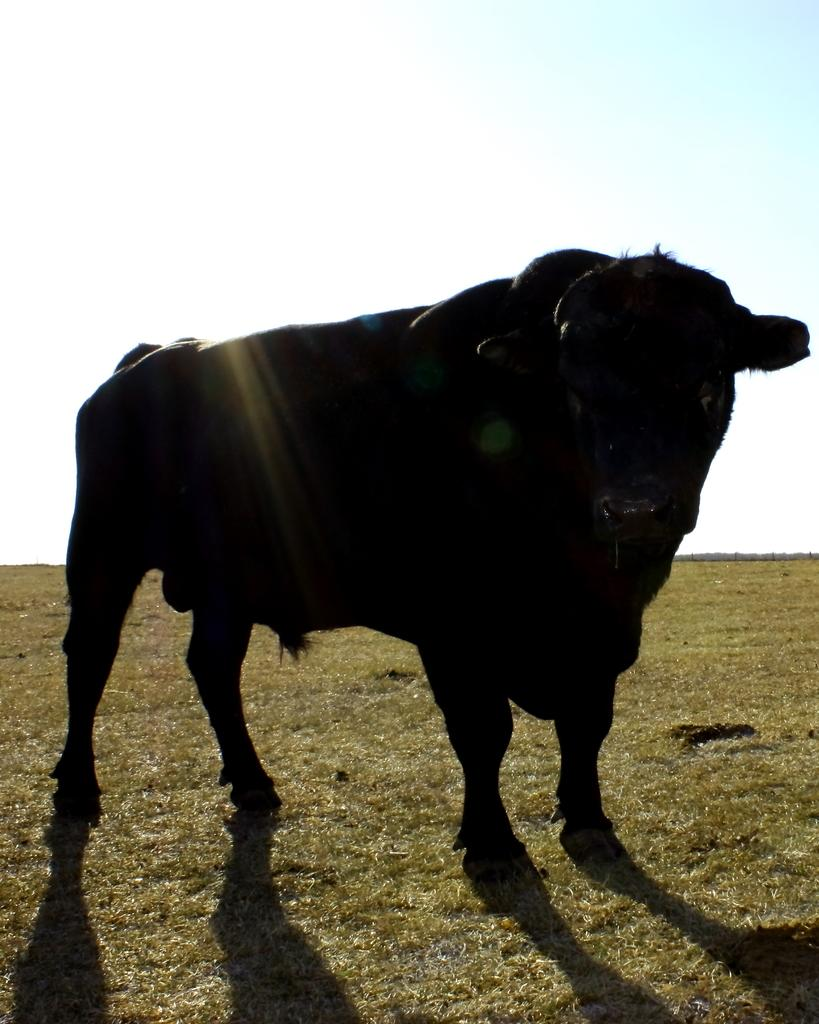What type of animal is in the image? There is a buffalo in the image. What shape is the coach that the buffalo is driving in the image? There is no coach present in the image, and the buffalo is not driving anything. 